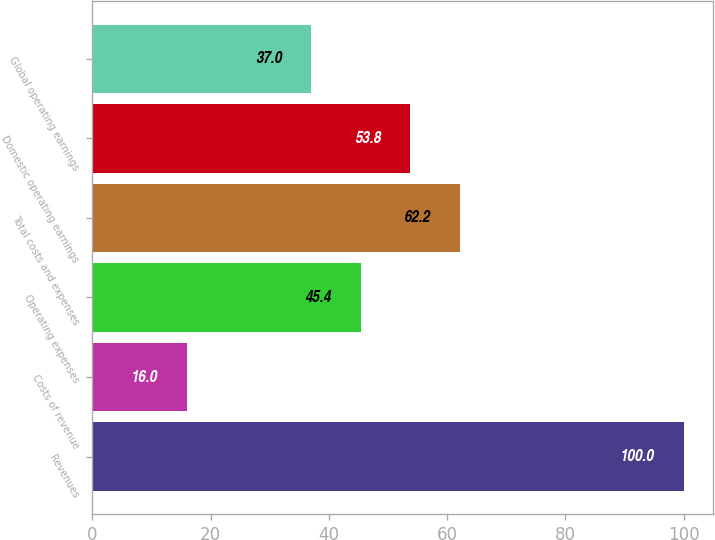Convert chart. <chart><loc_0><loc_0><loc_500><loc_500><bar_chart><fcel>Revenues<fcel>Costs of revenue<fcel>Operating expenses<fcel>Total costs and expenses<fcel>Domestic operating earnings<fcel>Global operating earnings<nl><fcel>100<fcel>16<fcel>45.4<fcel>62.2<fcel>53.8<fcel>37<nl></chart> 